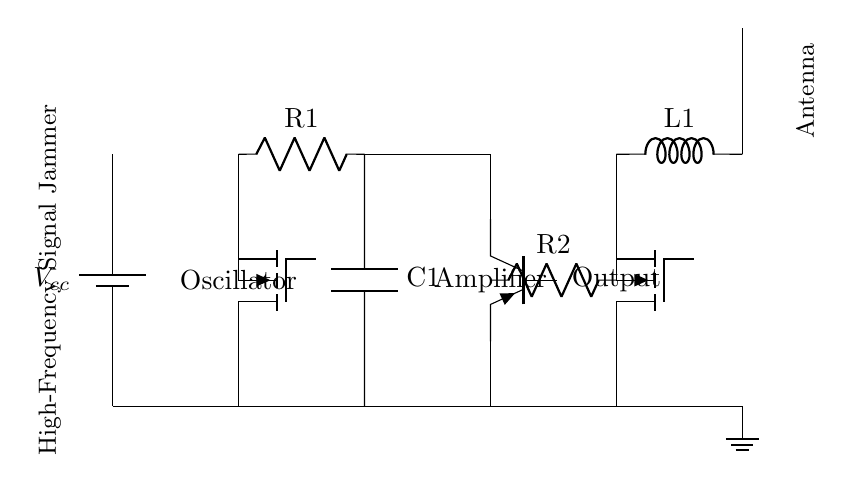What is the purpose of the oscillator in this circuit? The oscillator generates high-frequency signals necessary for jamming remote communications. It is the first component in the circuit and establishes the frequency that will be amplified and transmitted.
Answer: high-frequency signal generation What type of amplifier is used in the diagram? The amplifier used in the circuit is a PNP transistor amplifier, as indicated by the symbol and label in the diagram. This configuration allows for signal amplification to transmit higher power signals for jamming purposes.
Answer: PNP transistor What is the role of the capacitor in this circuit? The capacitor in this circuit acts as a filter to smooth out the voltages and help stabilize the signal produced by the oscillator before it reaches the amplifier stage, leading to a cleaner output signal.
Answer: smoothing the voltage What component is responsible for emitting the signal? The antenna is responsible for emitting the jamming signal generated and amplified by the circuit. It is located at the output stage of the circuit, allowing it to radiate signals into the environment effectively.
Answer: antenna How many resistors are in the circuit? There are two resistors in the circuit, labeled R1 and R2. Both resistors play crucial roles in controlling the current and voltage levels within the different stages of the circuit.
Answer: two What type of inductor is used in this circuit? The inductor used in the circuit is a standard inductor, labeled L1. This component is essential for tuning the output signal frequency and can be involved in filtering processes to help attenuate unwanted harmonics.
Answer: standard inductor What ensures the circuit is grounded? The ground node at the bottom of the circuit ensures that the entire circuit is connected to a common reference point, typically ground. This is essential for stability and safety in the operation of the circuit.
Answer: ground node 